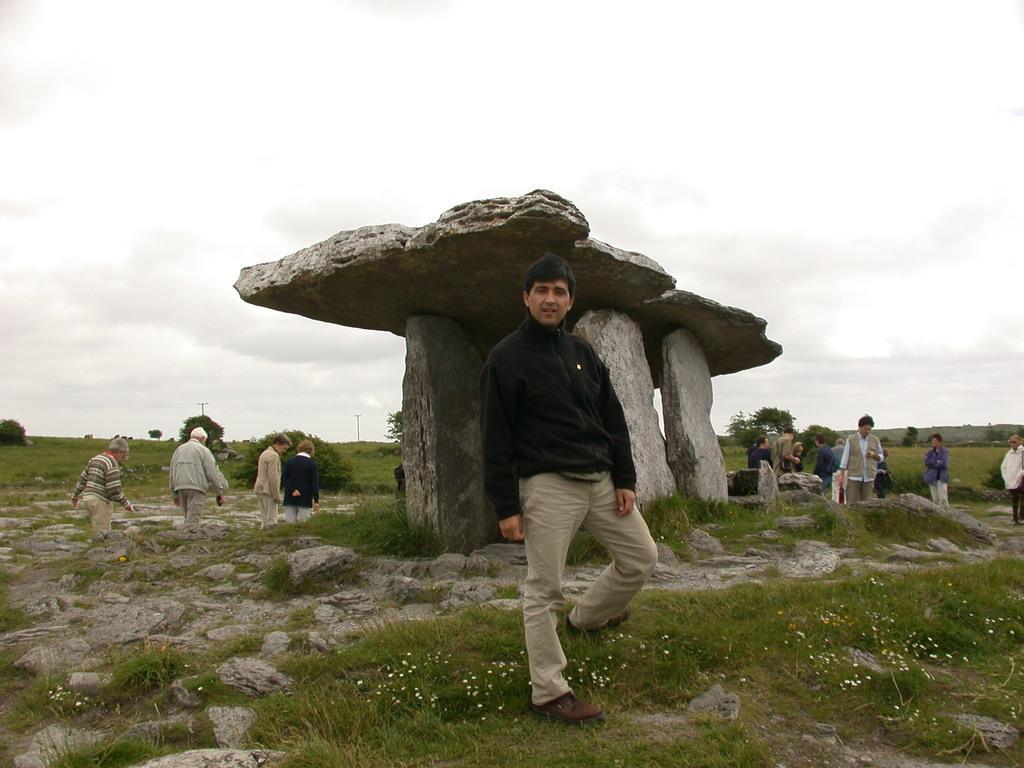Please provide a concise description of this image. In this picture I can see few standing around few stones and I can see the grass and few plants on the ground. In the background I can see the sky. 